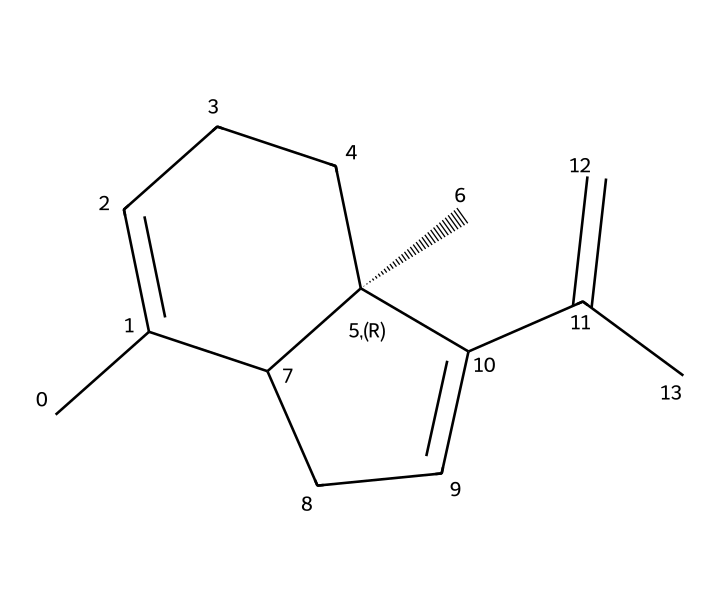What is the molecular formula of caryophyllene? To determine the molecular formula from the SMILES representation, you can count the number of carbon (C) and hydrogen (H) atoms. In this case, the structure shows a total of 15 carbon atoms and 24 hydrogen atoms. The molecular formula is then written as C15H24.
Answer: C15H24 How many rings are present in caryophyllene? By analyzing the structure within the SMILES, you can identify that there are two cyclic components indicated by the connectivity of the carbon atoms. Each cycle is represented distinctly, confirming the presence of two rings in total.
Answer: 2 What kind of chemical is caryophyllene categorized as? The SMILES structure reveals a classification typically identified by its particular use and structure. Given that caryophyllene is a hydrocarbon and specifically a bicyclic terpene, it is categorized as a terpene due to the arrangement of its carbon skeleton.
Answer: terpene What is the stereochemistry of caryophyllene? The SMILES notation includes the @ symbol indicating a chiral center, which points to specific stereochemistry. This chiral carbon corresponds to the stereocenter in the structure, indicating a specific three-dimensional arrangement characteristic of the compound.
Answer: chiral How many double bonds are in the structure of caryophyllene? Reviewing the drawn structure and the connections between the carbon atoms, you can identify the presence of double bonds visually based on the symbols in the structure. The analysis shows there are three double bonds present in caryophyllene.
Answer: 3 In what applications can caryophyllene be useful? Given the context of the question regarding sustainable agriculture and pest management, caryophyllene has been recognized for its potential use as a natural pesticide or repellent against various pests, making it particularly relevant in organic farming practices.
Answer: pest management 